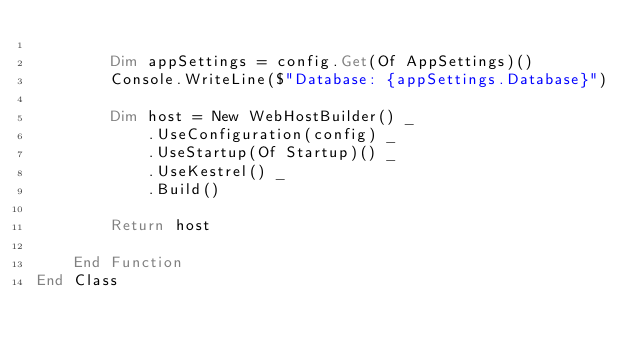Convert code to text. <code><loc_0><loc_0><loc_500><loc_500><_VisualBasic_>
        Dim appSettings = config.Get(Of AppSettings)()
        Console.WriteLine($"Database: {appSettings.Database}")

        Dim host = New WebHostBuilder() _
            .UseConfiguration(config) _
            .UseStartup(Of Startup)() _
            .UseKestrel() _
            .Build()

        Return host

    End Function
End Class
</code> 